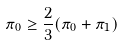Convert formula to latex. <formula><loc_0><loc_0><loc_500><loc_500>\pi _ { 0 } \geq \frac { 2 } { 3 } ( \pi _ { 0 } + \pi _ { 1 } )</formula> 